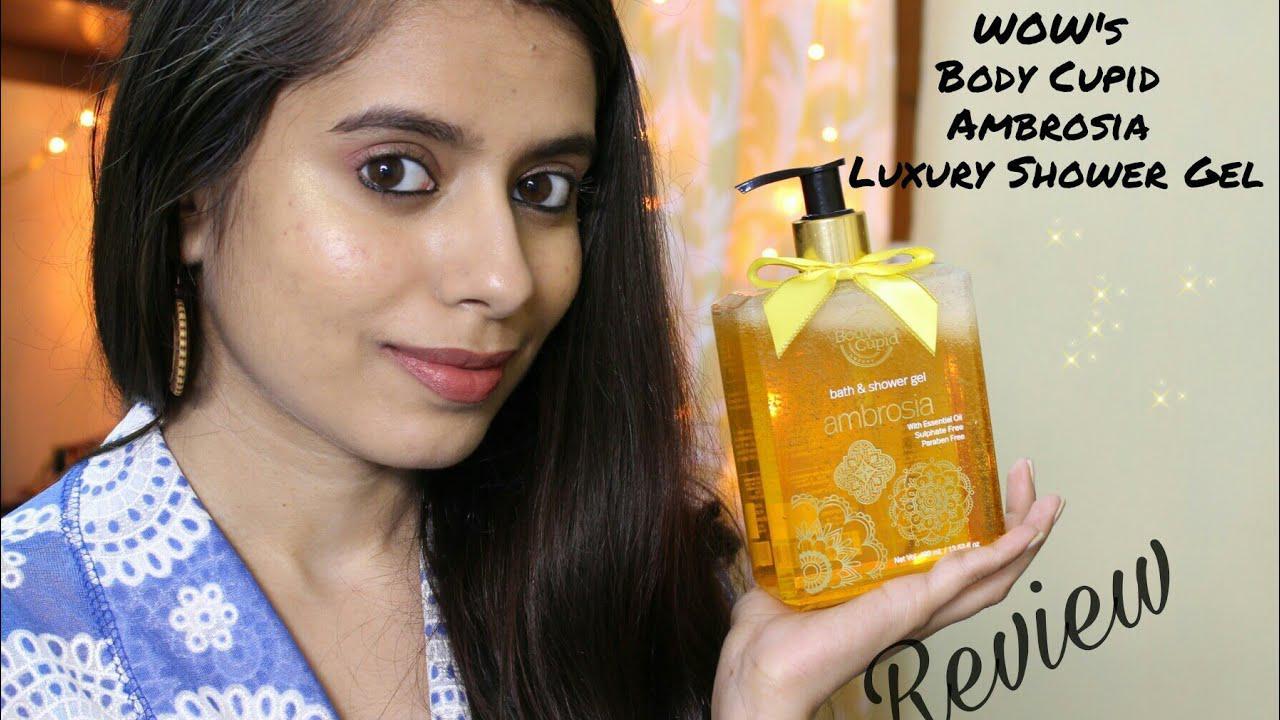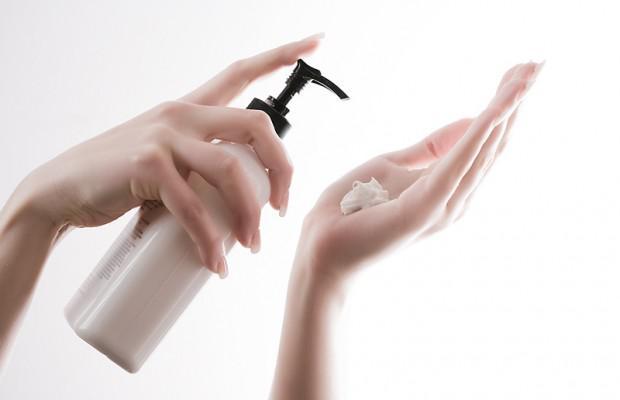The first image is the image on the left, the second image is the image on the right. Considering the images on both sides, is "A product is standing next to its box." valid? Answer yes or no. No. The first image is the image on the left, the second image is the image on the right. For the images displayed, is the sentence "Each image contains exactly one product with a black pump top, and one image features a pump bottle with a yellow bow, but the pump nozzles on the left and right face different directions." factually correct? Answer yes or no. Yes. 